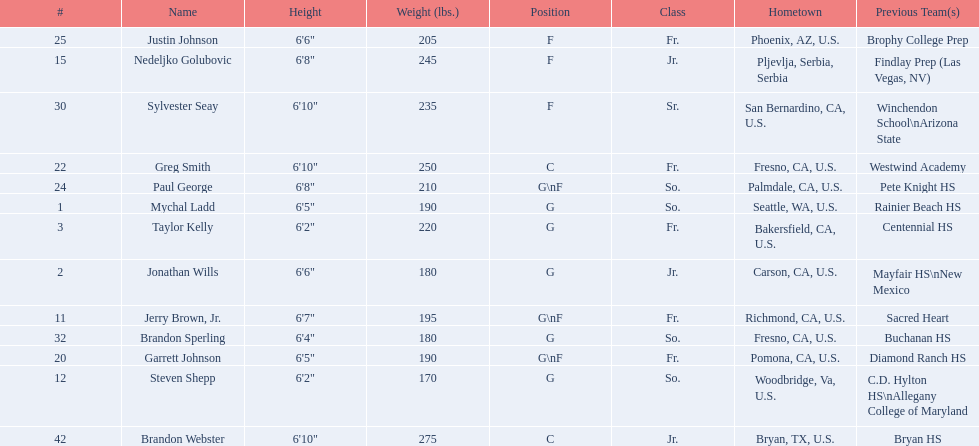What are the names of the basketball team players? Mychal Ladd, Jonathan Wills, Taylor Kelly, Jerry Brown, Jr., Steven Shepp, Nedeljko Golubovic, Garrett Johnson, Greg Smith, Paul George, Justin Johnson, Sylvester Seay, Brandon Sperling, Brandon Webster. Of these identify paul george and greg smith Greg Smith, Paul George. What are their corresponding heights? 6'10", 6'8". To who does the larger height correspond to? Greg Smith. 